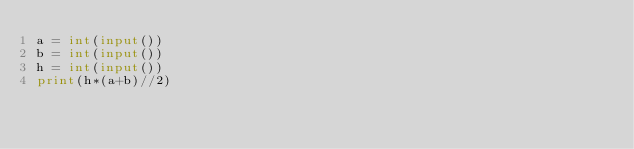Convert code to text. <code><loc_0><loc_0><loc_500><loc_500><_Python_>a = int(input())
b = int(input())
h = int(input())
print(h*(a+b)//2)</code> 